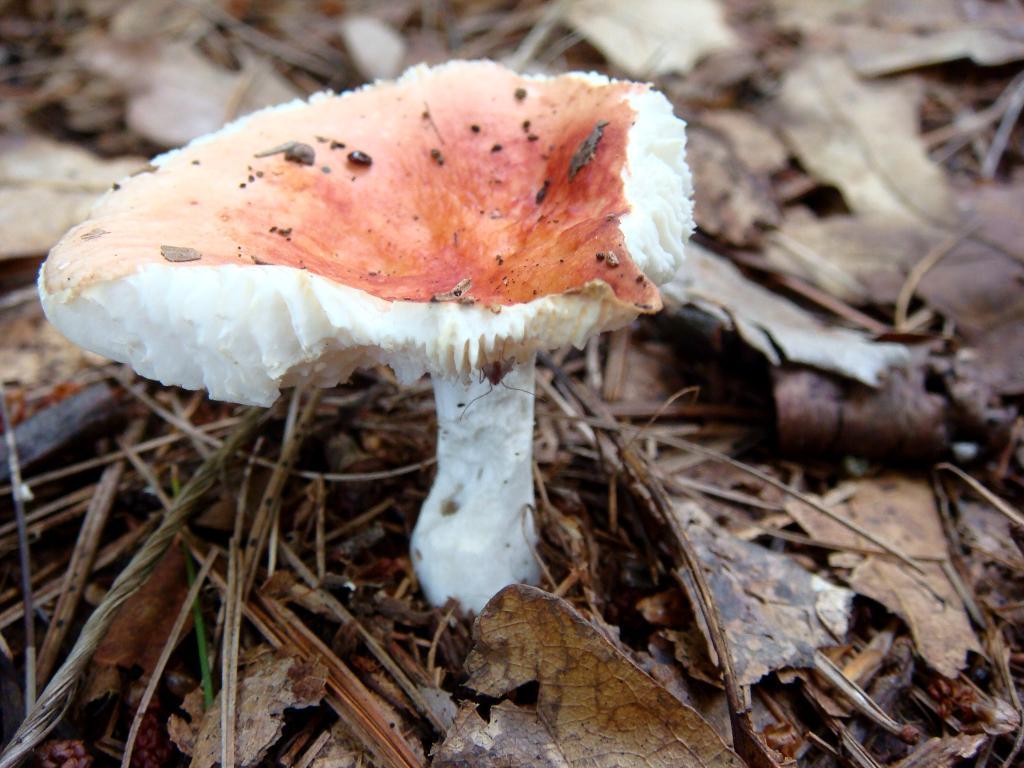Please provide a concise description of this image. We can see mushroom, grass and dried leaves. 